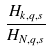<formula> <loc_0><loc_0><loc_500><loc_500>\frac { H _ { k , q , s } } { H _ { N , q , s } }</formula> 